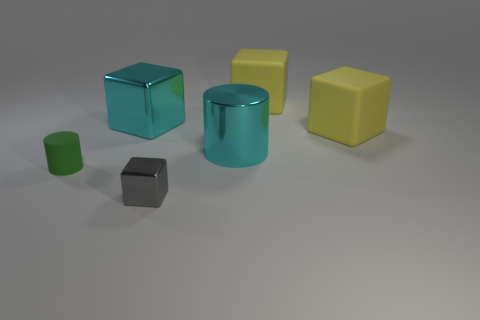Add 4 large cyan shiny cylinders. How many objects exist? 10 Subtract all red blocks. Subtract all brown cylinders. How many blocks are left? 4 Subtract all cylinders. How many objects are left? 4 Subtract all tiny green cylinders. Subtract all small gray metallic objects. How many objects are left? 4 Add 6 cyan objects. How many cyan objects are left? 8 Add 4 gray metallic objects. How many gray metallic objects exist? 5 Subtract 1 cyan cylinders. How many objects are left? 5 